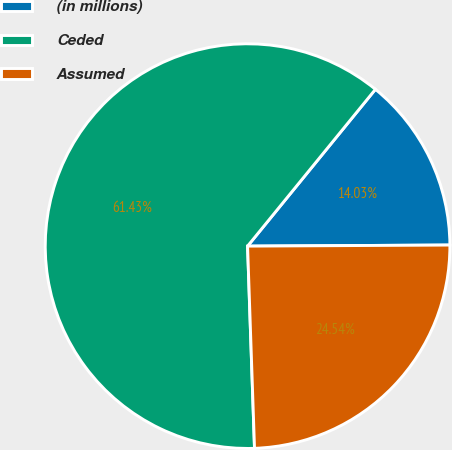<chart> <loc_0><loc_0><loc_500><loc_500><pie_chart><fcel>(in millions)<fcel>Ceded<fcel>Assumed<nl><fcel>14.03%<fcel>61.44%<fcel>24.54%<nl></chart> 